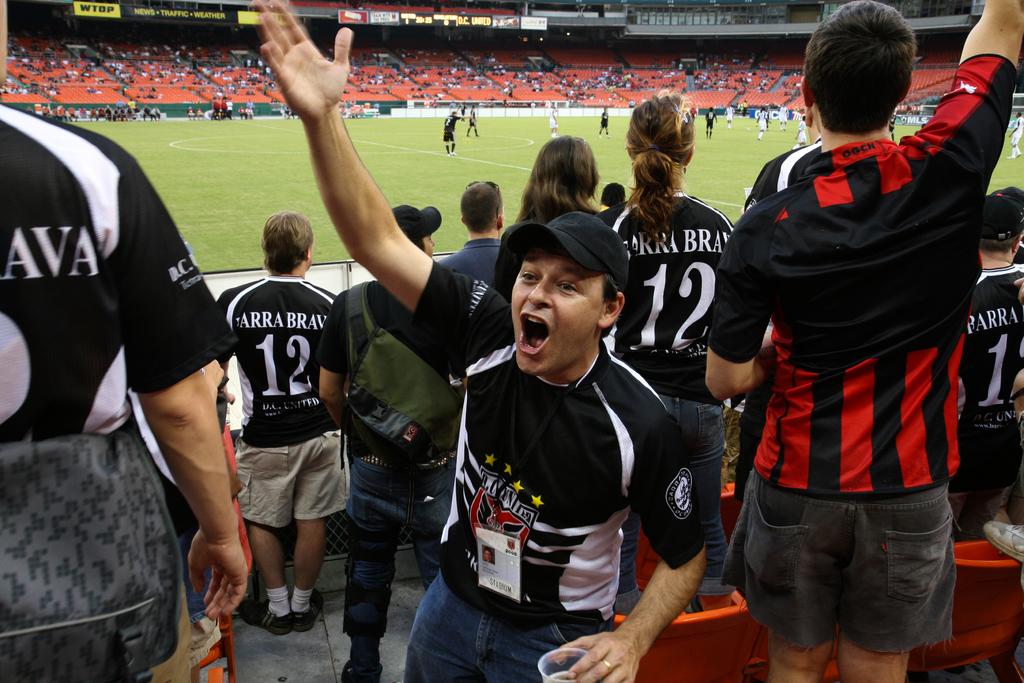What number is on the back of the fans' jerseys?
Offer a terse response. 12. 